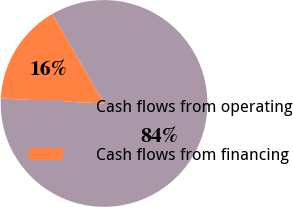Convert chart to OTSL. <chart><loc_0><loc_0><loc_500><loc_500><pie_chart><fcel>Cash flows from operating<fcel>Cash flows from financing<nl><fcel>84.11%<fcel>15.89%<nl></chart> 